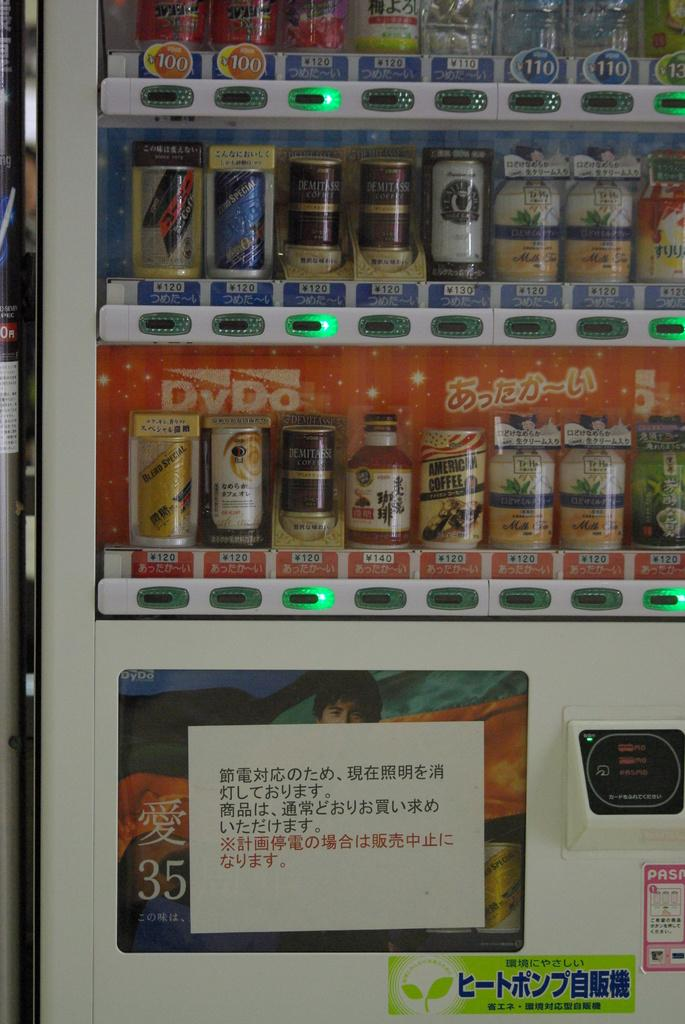<image>
Offer a succinct explanation of the picture presented. A soda machine with a lot of foreign writing on it with drinks costing 100 and 110. 